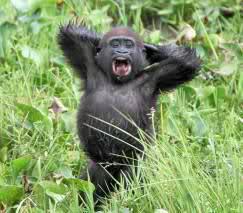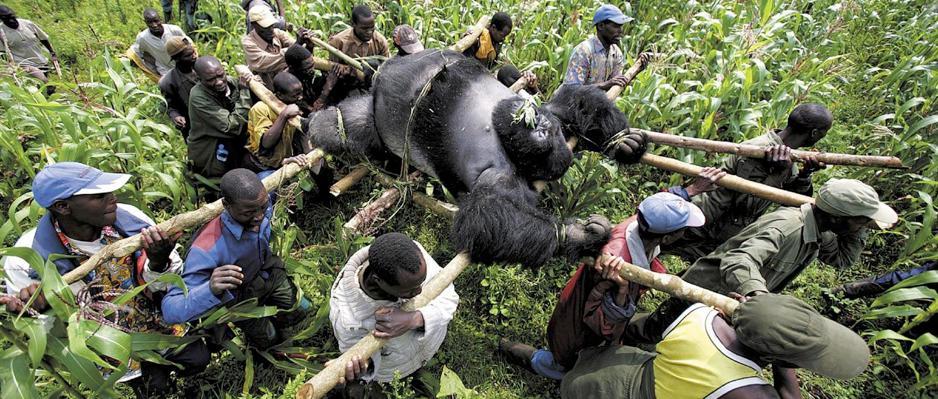The first image is the image on the left, the second image is the image on the right. Analyze the images presented: Is the assertion "There is one gorilla with its mouth wide open showing all of its teeth." valid? Answer yes or no. Yes. 